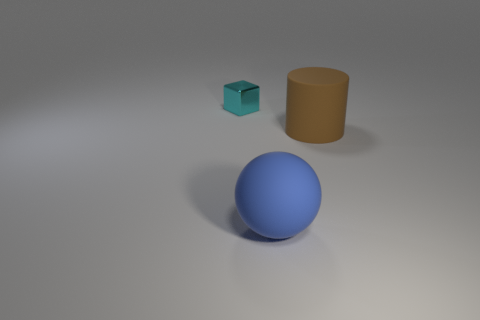What number of tiny purple rubber blocks are there?
Offer a very short reply. 0. What is the color of the object in front of the big rubber thing that is behind the blue sphere?
Offer a terse response. Blue. The thing that is the same size as the ball is what color?
Your answer should be compact. Brown. Is there a large cylinder of the same color as the big matte sphere?
Ensure brevity in your answer.  No. Are any gray matte balls visible?
Your answer should be very brief. No. The large object that is on the right side of the large blue matte ball has what shape?
Make the answer very short. Cylinder. How many objects are to the left of the blue rubber ball and to the right of the block?
Your response must be concise. 0. What number of other objects are there of the same size as the cyan shiny object?
Make the answer very short. 0. There is a rubber object on the left side of the brown object; is its shape the same as the object that is behind the cylinder?
Your answer should be very brief. No. What number of things are big matte objects or things in front of the cyan cube?
Your answer should be very brief. 2. 